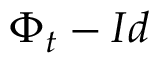Convert formula to latex. <formula><loc_0><loc_0><loc_500><loc_500>\Phi _ { t } - I d</formula> 